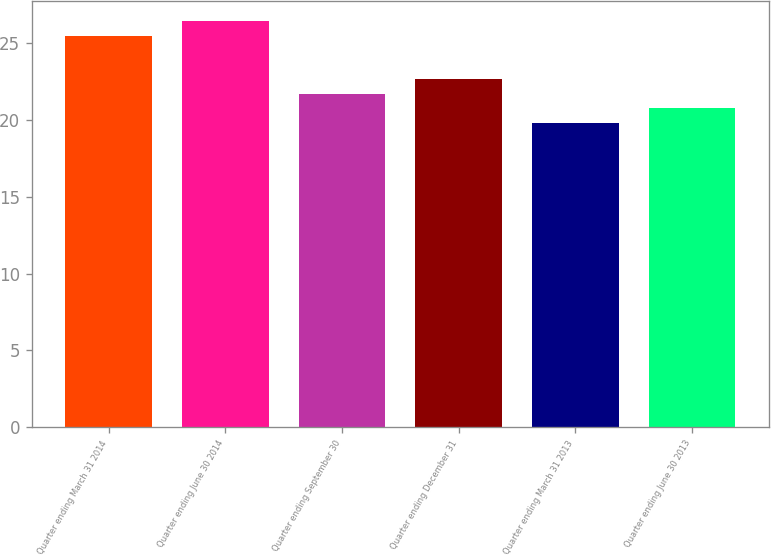<chart> <loc_0><loc_0><loc_500><loc_500><bar_chart><fcel>Quarter ending March 31 2014<fcel>Quarter ending June 30 2014<fcel>Quarter ending September 30<fcel>Quarter ending December 31<fcel>Quarter ending March 31 2013<fcel>Quarter ending June 30 2013<nl><fcel>25.47<fcel>26.44<fcel>21.72<fcel>22.69<fcel>19.78<fcel>20.75<nl></chart> 